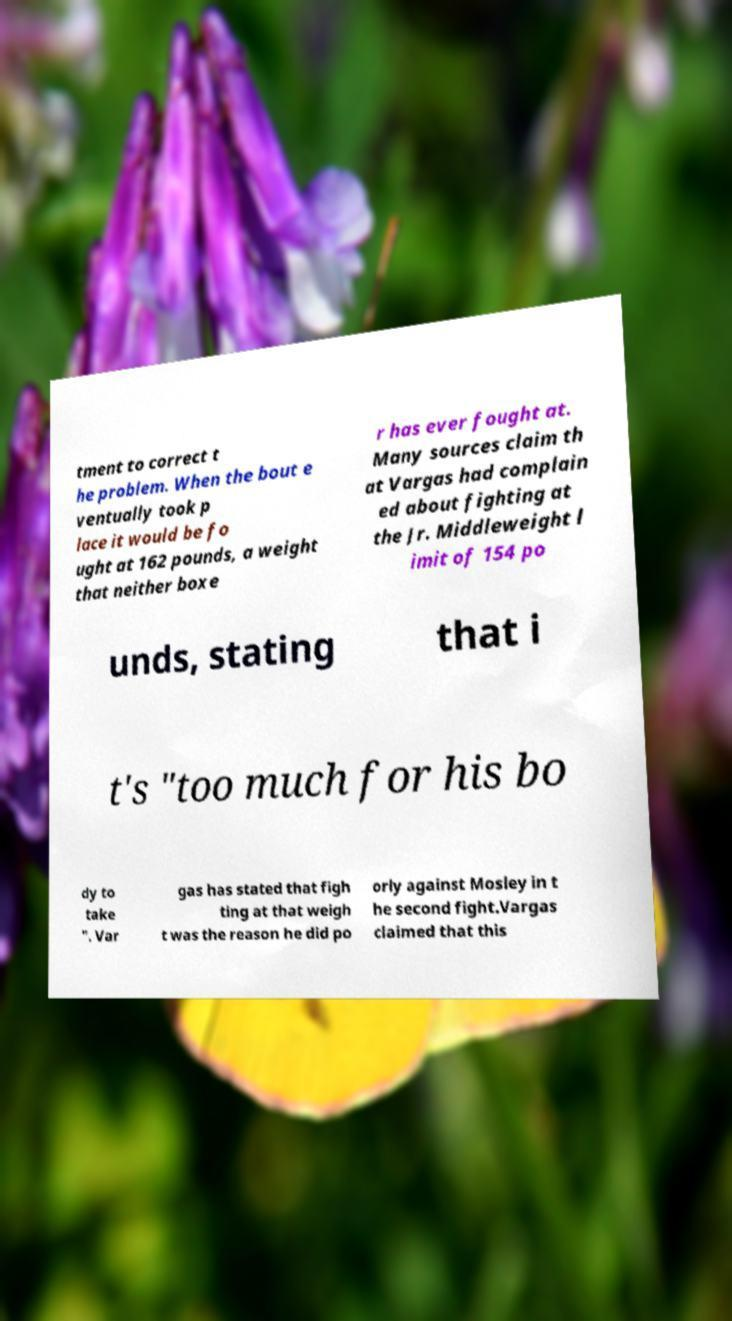Please read and relay the text visible in this image. What does it say? tment to correct t he problem. When the bout e ventually took p lace it would be fo ught at 162 pounds, a weight that neither boxe r has ever fought at. Many sources claim th at Vargas had complain ed about fighting at the Jr. Middleweight l imit of 154 po unds, stating that i t's "too much for his bo dy to take ". Var gas has stated that figh ting at that weigh t was the reason he did po orly against Mosley in t he second fight.Vargas claimed that this 